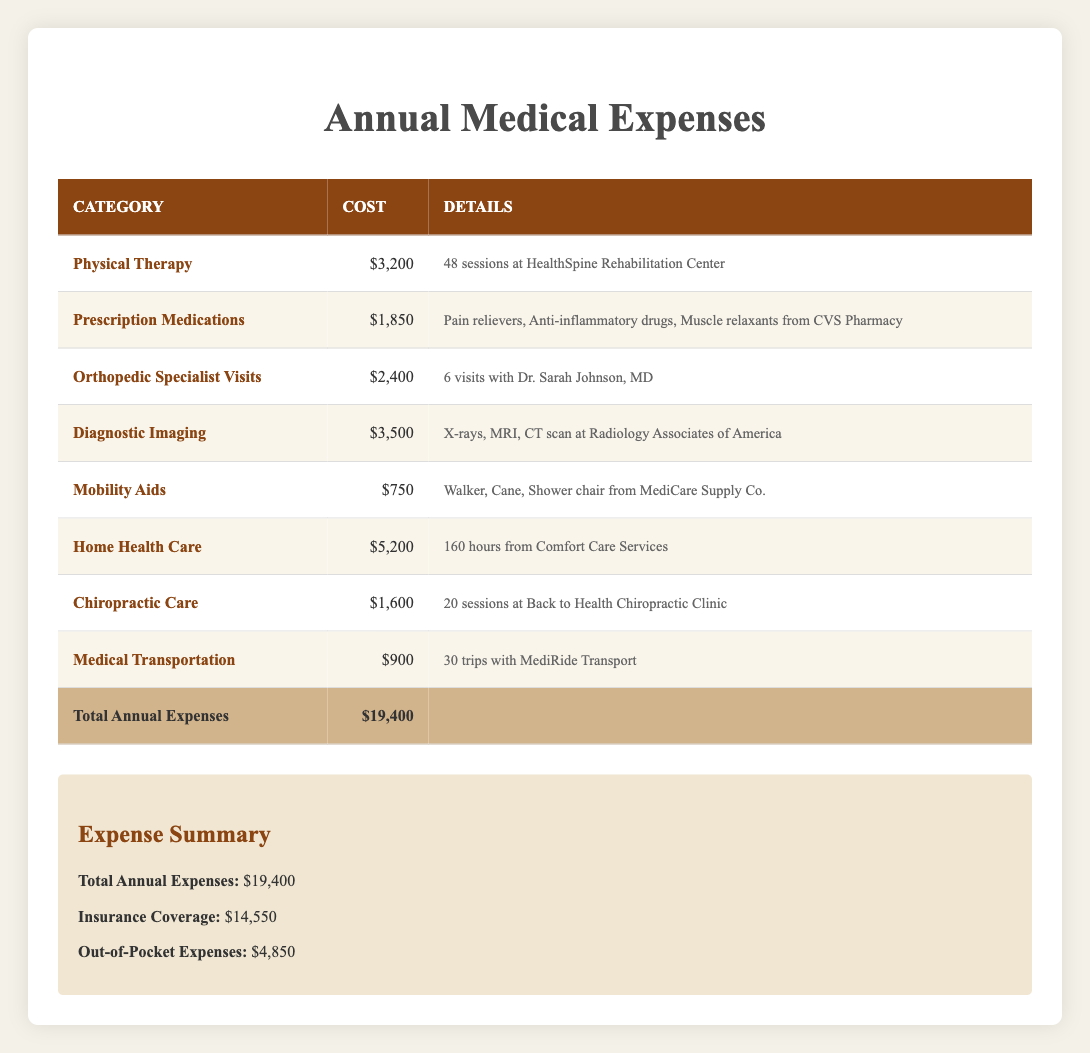What is the total cost for Home Health Care? The table indicates that the cost for Home Health Care is listed directly as $5,200.
Answer: $5,200 How many sessions of Physical Therapy were conducted? The table notes that there were 48 sessions of Physical Therapy.
Answer: 48 What is the total cost for all medical expenses? The total annual expenses listed in the table are $19,400, which combines costs from all categories.
Answer: $19,400 Are the Prescription Medications covered by insurance? The table does not specify which categories are covered by insurance, only the total insurance coverage of $14,550 is provided. Thus, it cannot be definitively stated that Prescription Medications are covered.
Answer: No What is the difference between the total annual expenses and insurance coverage? To determine the difference, subtract the insurance coverage of $14,550 from the total expenses of $19,400, which equals $4,850.
Answer: $4,850 Which category has the highest annual medical expense? By examining the costs for each category, Diagnostic Imaging has the highest expense at $3,500.
Answer: Diagnostic Imaging If I am interested in the total cost for therapy-related services (Physical Therapy and Chiropractic Care), what would it be? Add the costs of Physical Therapy ($3,200) and Chiropractic Care ($1,600). The total becomes $3,200 + $1,600 = $4,800.
Answer: $4,800 Are the mobility aids cost less than or equal to the amount spent on Prescription Medications? The Mobility Aids cost $750, and the Prescription Medications cost $1,850. Since $750 is less than $1,850, the statement is true.
Answer: Yes What percentage of the total expenses is out-of-pocket? To find the percentage, divide the out-of-pocket expenses ($4,850) by the total expenses ($19,400) and multiply by 100. This equals ($4,850 / $19,400) * 100 = approximately 24.98%.
Answer: 25% 